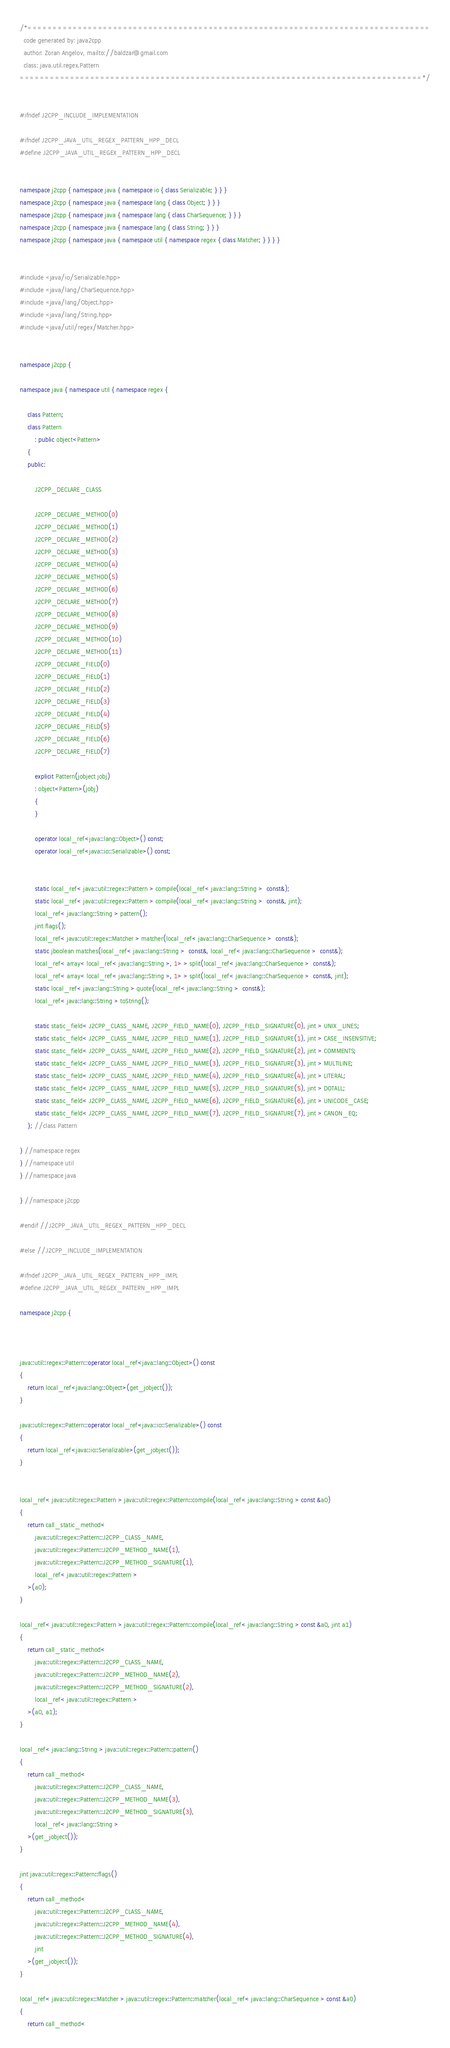<code> <loc_0><loc_0><loc_500><loc_500><_C++_>/*================================================================================
  code generated by: java2cpp
  author: Zoran Angelov, mailto://baldzar@gmail.com
  class: java.util.regex.Pattern
================================================================================*/


#ifndef J2CPP_INCLUDE_IMPLEMENTATION

#ifndef J2CPP_JAVA_UTIL_REGEX_PATTERN_HPP_DECL
#define J2CPP_JAVA_UTIL_REGEX_PATTERN_HPP_DECL


namespace j2cpp { namespace java { namespace io { class Serializable; } } }
namespace j2cpp { namespace java { namespace lang { class Object; } } }
namespace j2cpp { namespace java { namespace lang { class CharSequence; } } }
namespace j2cpp { namespace java { namespace lang { class String; } } }
namespace j2cpp { namespace java { namespace util { namespace regex { class Matcher; } } } }


#include <java/io/Serializable.hpp>
#include <java/lang/CharSequence.hpp>
#include <java/lang/Object.hpp>
#include <java/lang/String.hpp>
#include <java/util/regex/Matcher.hpp>


namespace j2cpp {

namespace java { namespace util { namespace regex {

	class Pattern;
	class Pattern
		: public object<Pattern>
	{
	public:

		J2CPP_DECLARE_CLASS

		J2CPP_DECLARE_METHOD(0)
		J2CPP_DECLARE_METHOD(1)
		J2CPP_DECLARE_METHOD(2)
		J2CPP_DECLARE_METHOD(3)
		J2CPP_DECLARE_METHOD(4)
		J2CPP_DECLARE_METHOD(5)
		J2CPP_DECLARE_METHOD(6)
		J2CPP_DECLARE_METHOD(7)
		J2CPP_DECLARE_METHOD(8)
		J2CPP_DECLARE_METHOD(9)
		J2CPP_DECLARE_METHOD(10)
		J2CPP_DECLARE_METHOD(11)
		J2CPP_DECLARE_FIELD(0)
		J2CPP_DECLARE_FIELD(1)
		J2CPP_DECLARE_FIELD(2)
		J2CPP_DECLARE_FIELD(3)
		J2CPP_DECLARE_FIELD(4)
		J2CPP_DECLARE_FIELD(5)
		J2CPP_DECLARE_FIELD(6)
		J2CPP_DECLARE_FIELD(7)

		explicit Pattern(jobject jobj)
		: object<Pattern>(jobj)
		{
		}

		operator local_ref<java::lang::Object>() const;
		operator local_ref<java::io::Serializable>() const;


		static local_ref< java::util::regex::Pattern > compile(local_ref< java::lang::String >  const&);
		static local_ref< java::util::regex::Pattern > compile(local_ref< java::lang::String >  const&, jint);
		local_ref< java::lang::String > pattern();
		jint flags();
		local_ref< java::util::regex::Matcher > matcher(local_ref< java::lang::CharSequence >  const&);
		static jboolean matches(local_ref< java::lang::String >  const&, local_ref< java::lang::CharSequence >  const&);
		local_ref< array< local_ref< java::lang::String >, 1> > split(local_ref< java::lang::CharSequence >  const&);
		local_ref< array< local_ref< java::lang::String >, 1> > split(local_ref< java::lang::CharSequence >  const&, jint);
		static local_ref< java::lang::String > quote(local_ref< java::lang::String >  const&);
		local_ref< java::lang::String > toString();

		static static_field< J2CPP_CLASS_NAME, J2CPP_FIELD_NAME(0), J2CPP_FIELD_SIGNATURE(0), jint > UNIX_LINES;
		static static_field< J2CPP_CLASS_NAME, J2CPP_FIELD_NAME(1), J2CPP_FIELD_SIGNATURE(1), jint > CASE_INSENSITIVE;
		static static_field< J2CPP_CLASS_NAME, J2CPP_FIELD_NAME(2), J2CPP_FIELD_SIGNATURE(2), jint > COMMENTS;
		static static_field< J2CPP_CLASS_NAME, J2CPP_FIELD_NAME(3), J2CPP_FIELD_SIGNATURE(3), jint > MULTILINE;
		static static_field< J2CPP_CLASS_NAME, J2CPP_FIELD_NAME(4), J2CPP_FIELD_SIGNATURE(4), jint > LITERAL;
		static static_field< J2CPP_CLASS_NAME, J2CPP_FIELD_NAME(5), J2CPP_FIELD_SIGNATURE(5), jint > DOTALL;
		static static_field< J2CPP_CLASS_NAME, J2CPP_FIELD_NAME(6), J2CPP_FIELD_SIGNATURE(6), jint > UNICODE_CASE;
		static static_field< J2CPP_CLASS_NAME, J2CPP_FIELD_NAME(7), J2CPP_FIELD_SIGNATURE(7), jint > CANON_EQ;
	}; //class Pattern

} //namespace regex
} //namespace util
} //namespace java

} //namespace j2cpp

#endif //J2CPP_JAVA_UTIL_REGEX_PATTERN_HPP_DECL

#else //J2CPP_INCLUDE_IMPLEMENTATION

#ifndef J2CPP_JAVA_UTIL_REGEX_PATTERN_HPP_IMPL
#define J2CPP_JAVA_UTIL_REGEX_PATTERN_HPP_IMPL

namespace j2cpp {



java::util::regex::Pattern::operator local_ref<java::lang::Object>() const
{
	return local_ref<java::lang::Object>(get_jobject());
}

java::util::regex::Pattern::operator local_ref<java::io::Serializable>() const
{
	return local_ref<java::io::Serializable>(get_jobject());
}


local_ref< java::util::regex::Pattern > java::util::regex::Pattern::compile(local_ref< java::lang::String > const &a0)
{
	return call_static_method<
		java::util::regex::Pattern::J2CPP_CLASS_NAME,
		java::util::regex::Pattern::J2CPP_METHOD_NAME(1),
		java::util::regex::Pattern::J2CPP_METHOD_SIGNATURE(1), 
		local_ref< java::util::regex::Pattern >
	>(a0);
}

local_ref< java::util::regex::Pattern > java::util::regex::Pattern::compile(local_ref< java::lang::String > const &a0, jint a1)
{
	return call_static_method<
		java::util::regex::Pattern::J2CPP_CLASS_NAME,
		java::util::regex::Pattern::J2CPP_METHOD_NAME(2),
		java::util::regex::Pattern::J2CPP_METHOD_SIGNATURE(2), 
		local_ref< java::util::regex::Pattern >
	>(a0, a1);
}

local_ref< java::lang::String > java::util::regex::Pattern::pattern()
{
	return call_method<
		java::util::regex::Pattern::J2CPP_CLASS_NAME,
		java::util::regex::Pattern::J2CPP_METHOD_NAME(3),
		java::util::regex::Pattern::J2CPP_METHOD_SIGNATURE(3), 
		local_ref< java::lang::String >
	>(get_jobject());
}

jint java::util::regex::Pattern::flags()
{
	return call_method<
		java::util::regex::Pattern::J2CPP_CLASS_NAME,
		java::util::regex::Pattern::J2CPP_METHOD_NAME(4),
		java::util::regex::Pattern::J2CPP_METHOD_SIGNATURE(4), 
		jint
	>(get_jobject());
}

local_ref< java::util::regex::Matcher > java::util::regex::Pattern::matcher(local_ref< java::lang::CharSequence > const &a0)
{
	return call_method<</code> 